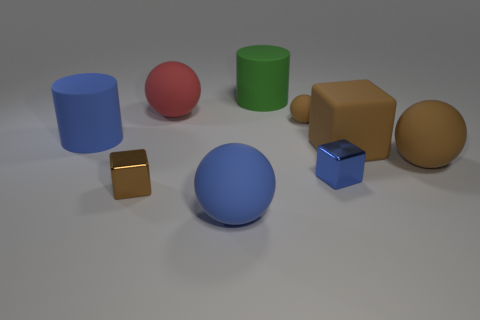Subtract 1 spheres. How many spheres are left? 3 Add 1 blue spheres. How many objects exist? 10 Subtract all blocks. How many objects are left? 6 Add 2 metallic objects. How many metallic objects exist? 4 Subtract 1 blue cylinders. How many objects are left? 8 Subtract all spheres. Subtract all big matte cylinders. How many objects are left? 3 Add 5 big brown matte things. How many big brown matte things are left? 7 